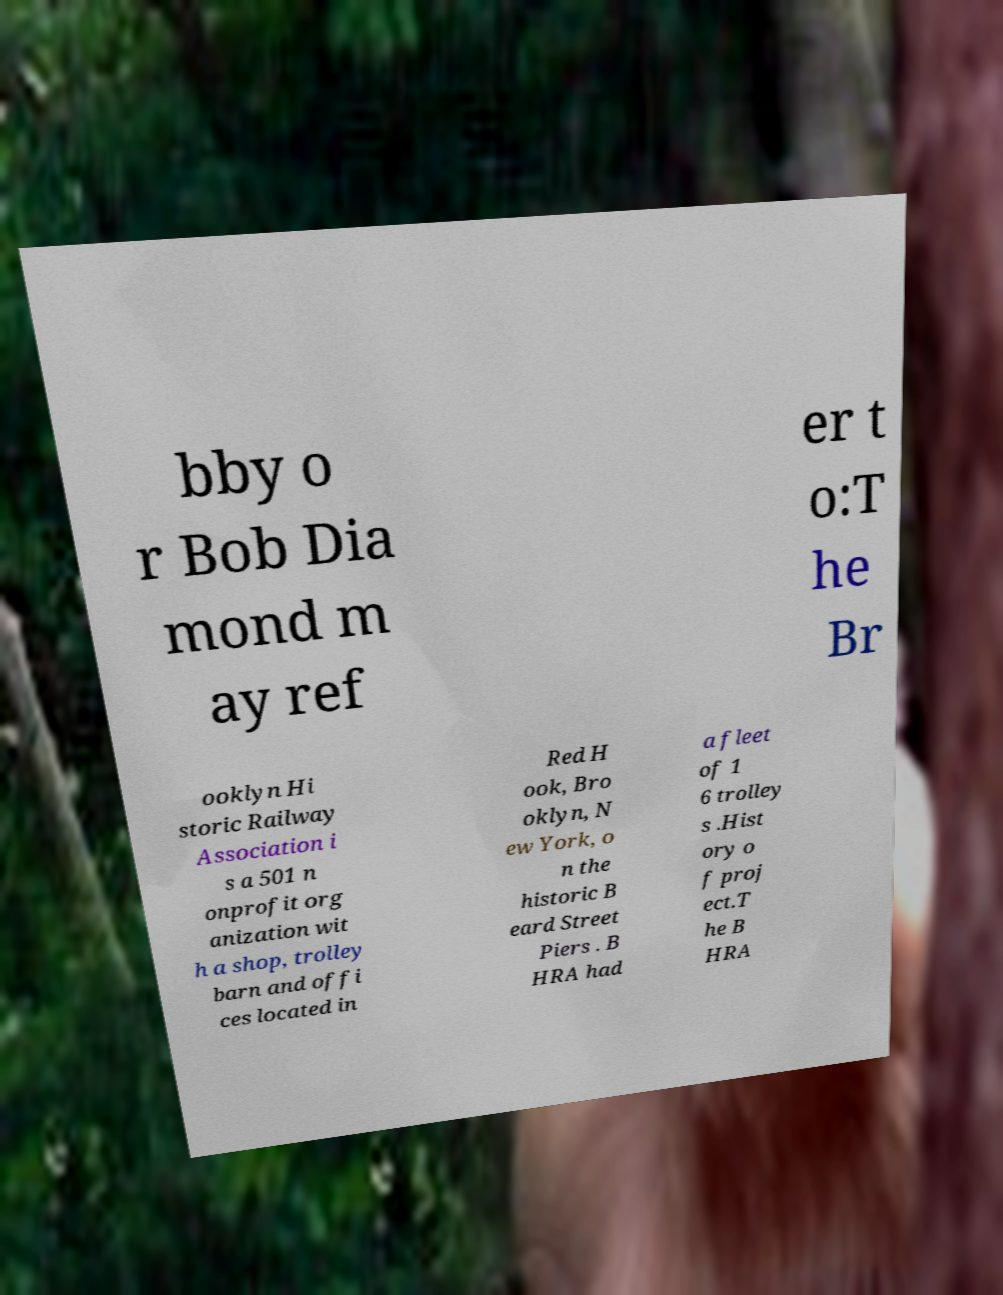I need the written content from this picture converted into text. Can you do that? bby o r Bob Dia mond m ay ref er t o:T he Br ooklyn Hi storic Railway Association i s a 501 n onprofit org anization wit h a shop, trolley barn and offi ces located in Red H ook, Bro oklyn, N ew York, o n the historic B eard Street Piers . B HRA had a fleet of 1 6 trolley s .Hist ory o f proj ect.T he B HRA 